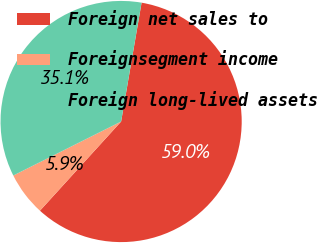Convert chart to OTSL. <chart><loc_0><loc_0><loc_500><loc_500><pie_chart><fcel>Foreign net sales to<fcel>Foreignsegment income<fcel>Foreign long-lived assets<nl><fcel>59.04%<fcel>5.86%<fcel>35.1%<nl></chart> 